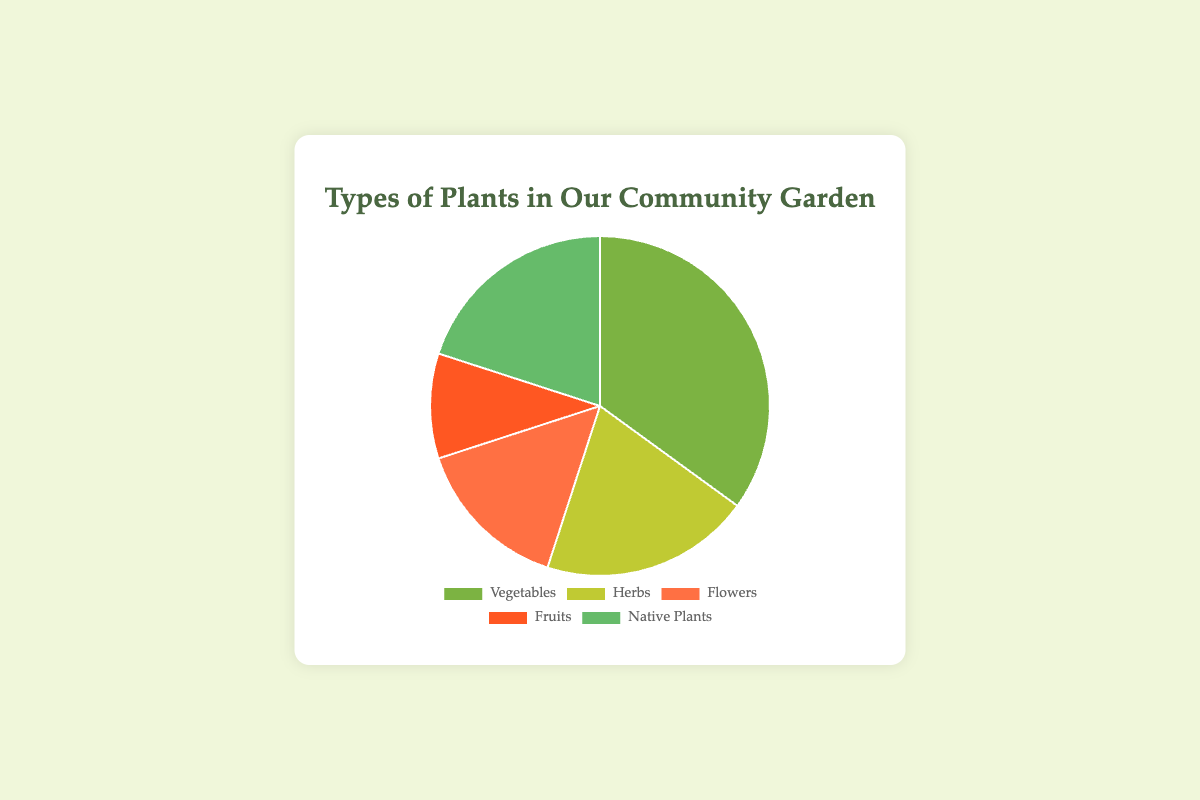What is the percentage of vegetables in the community garden? The chart shows that vegetables comprise 35% of the plants in the community garden.
Answer: 35% Which type of plant occupies the least percentage in the garden? By looking at the segments in the pie chart, fruits occupy the smallest section with 10%.
Answer: Fruits What is the total percentage of herbs and native plants combined? Combine the percentages of herbs (20%) and native plants (20%) to get the total: 20% + 20% = 40%.
Answer: 40% Are there more herbs or flowers in the garden? The chart shows that herbs (20%) comprise a larger portion compared to flowers (15%).
Answer: Herbs What is the difference in percentage between vegetables and fruits? To find the difference, subtract the percentage of fruits (10%) from vegetables (35%): 35% - 10% = 25%.
Answer: 25% Which types of plants together make up half of the garden? Vegetables (35%) and herbs (20%) together form 55%, whereas vegetables and native plants make 35% + 20% = 55%. Hence, herbs and native plants (both 20%) together form 40% which is not half. Thus, no combination of two types makes exactly 50%. Vegetables and flowers make 35% + 15% = 50%.
Answer: Vegetables and Flowers What are the colors associated with the vegetables and the flowers in the pie chart? Vegetables are represented by green (#7CB342) and flowers by orange (#FF7043) in the pie chart.
Answer: Green and Orange If the garden increases the percentage of native plants by 5%, reducing vegetables by the same amount, what would the new percentage for each be? Native plants' percentage would increase from 20% to 25%, and vegetables would decrease from 35% to 30%.
Answer: Native Plants: 25%, Vegetables: 30% Which group, herbs or native plants, occupies a larger portion of the pie chart, and by what percentage? Both herbs and native plants occupy an equal portion of 20% each in the pie chart.
Answer: Equal, 20% If flowers were doubled in percentage, reducing other categories equally, what would the new percentage of flowers be? Doubling flowers means 15% x 2 = 30%. Total initial percentage = 100%. Therefore, the remaining 70% is to be redistributed, hence each type would reduce equally by 5%: (35-5)%, (20-5)%, (10-5)%, and (20-5)%, leading to new percentages for vegetables (30%), herbs (15%), fruits (5%), native plants (15%) and flowers (30%).
Answer: Flowers: 30% 